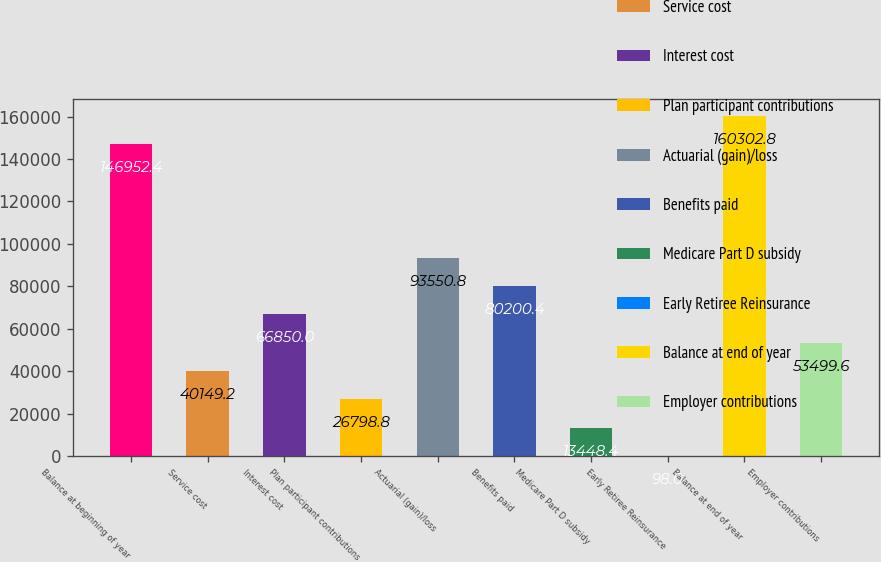<chart> <loc_0><loc_0><loc_500><loc_500><bar_chart><fcel>Balance at beginning of year<fcel>Service cost<fcel>Interest cost<fcel>Plan participant contributions<fcel>Actuarial (gain)/loss<fcel>Benefits paid<fcel>Medicare Part D subsidy<fcel>Early Retiree Reinsurance<fcel>Balance at end of year<fcel>Employer contributions<nl><fcel>146952<fcel>40149.2<fcel>66850<fcel>26798.8<fcel>93550.8<fcel>80200.4<fcel>13448.4<fcel>98<fcel>160303<fcel>53499.6<nl></chart> 